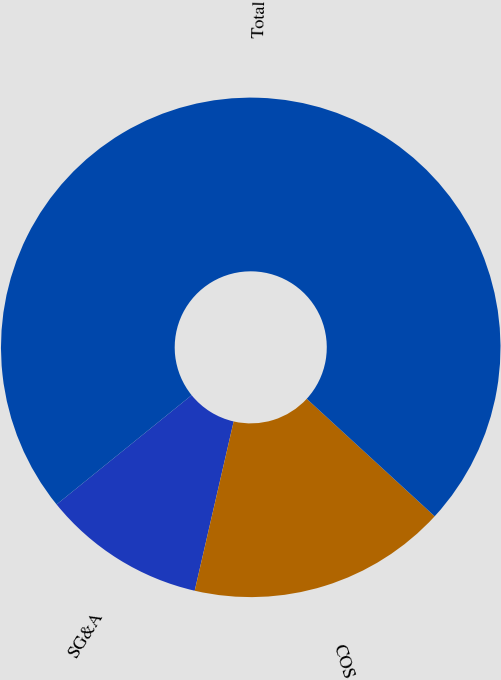<chart> <loc_0><loc_0><loc_500><loc_500><pie_chart><fcel>SG&A<fcel>COS<fcel>Total<nl><fcel>10.57%<fcel>16.78%<fcel>72.65%<nl></chart> 